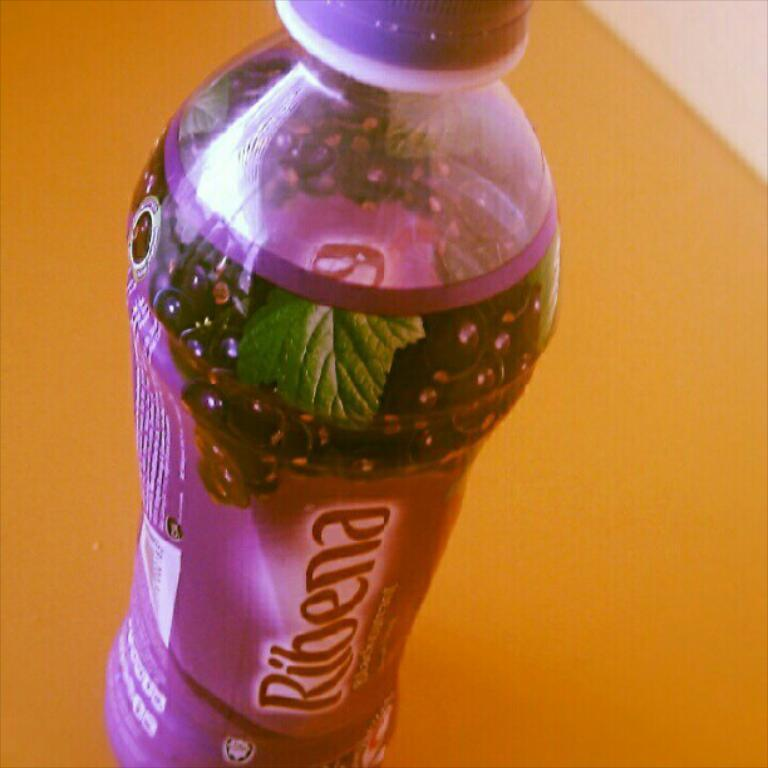What object is present in the image that can hold a drink? There is a bottle in the image that can hold a drink. What is inside the bottle? There is a drink in the bottle. Is there any information or design on the bottle? Yes, the bottle has a label. How many birds are perched on the foot of the person holding the bottle in the image? There is no person holding the bottle in the image, nor are there any birds present. 